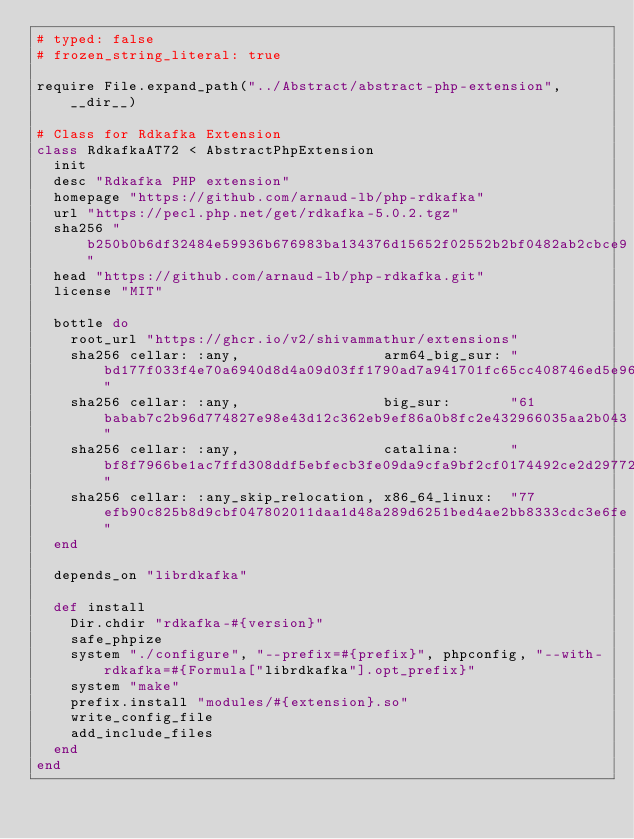<code> <loc_0><loc_0><loc_500><loc_500><_Ruby_># typed: false
# frozen_string_literal: true

require File.expand_path("../Abstract/abstract-php-extension", __dir__)

# Class for Rdkafka Extension
class RdkafkaAT72 < AbstractPhpExtension
  init
  desc "Rdkafka PHP extension"
  homepage "https://github.com/arnaud-lb/php-rdkafka"
  url "https://pecl.php.net/get/rdkafka-5.0.2.tgz"
  sha256 "b250b0b6df32484e59936b676983ba134376d15652f02552b2bf0482ab2cbce9"
  head "https://github.com/arnaud-lb/php-rdkafka.git"
  license "MIT"

  bottle do
    root_url "https://ghcr.io/v2/shivammathur/extensions"
    sha256 cellar: :any,                 arm64_big_sur: "bd177f033f4e70a6940d8d4a09d03ff1790ad7a941701fc65cc408746ed5e961"
    sha256 cellar: :any,                 big_sur:       "61babab7c2b96d774827e98e43d12c362eb9ef86a0b8fc2e432966035aa2b043"
    sha256 cellar: :any,                 catalina:      "bf8f7966be1ac7ffd308ddf5ebfecb3fe09da9cfa9bf2cf0174492ce2d297722"
    sha256 cellar: :any_skip_relocation, x86_64_linux:  "77efb90c825b8d9cbf047802011daa1d48a289d6251bed4ae2bb8333cdc3e6fe"
  end

  depends_on "librdkafka"

  def install
    Dir.chdir "rdkafka-#{version}"
    safe_phpize
    system "./configure", "--prefix=#{prefix}", phpconfig, "--with-rdkafka=#{Formula["librdkafka"].opt_prefix}"
    system "make"
    prefix.install "modules/#{extension}.so"
    write_config_file
    add_include_files
  end
end
</code> 